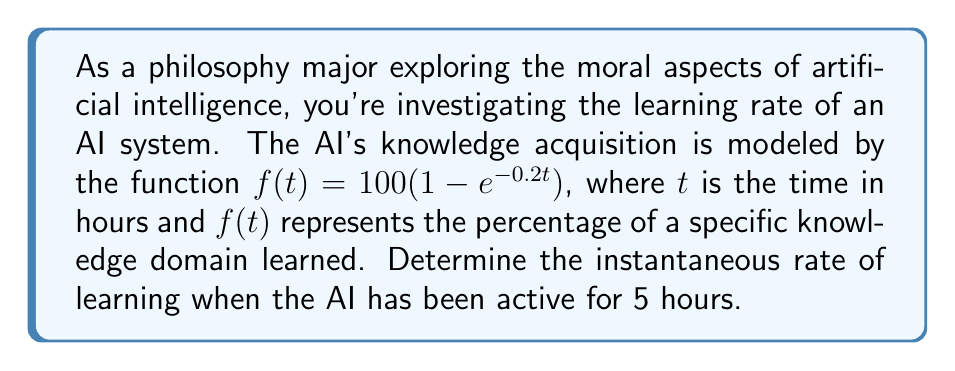Help me with this question. To solve this problem, we need to find the derivative of the given function and evaluate it at $t=5$. This will give us the instantaneous rate of change, or the learning rate, at that specific time.

1. Given function: $f(t) = 100(1 - e^{-0.2t})$

2. To find the derivative, we use the chain rule:
   $$\frac{d}{dt}[f(t)] = 100 \cdot \frac{d}{dt}[1 - e^{-0.2t}]$$
   $$= 100 \cdot (-1) \cdot \frac{d}{dt}[e^{-0.2t}]$$
   $$= -100 \cdot e^{-0.2t} \cdot \frac{d}{dt}[-0.2t]$$
   $$= -100 \cdot e^{-0.2t} \cdot (-0.2)$$
   $$= 20 \cdot e^{-0.2t}$$

3. So, the derivative (rate of change) function is:
   $$f'(t) = 20e^{-0.2t}$$

4. To find the instantaneous rate of learning at $t=5$, we evaluate $f'(5)$:
   $$f'(5) = 20e^{-0.2(5)}$$
   $$= 20e^{-1}$$
   $$= 20 \cdot \frac{1}{e}$$
   $$\approx 7.3576$$

This result represents the percentage increase in knowledge per hour at $t=5$.
Answer: The instantaneous rate of learning when the AI has been active for 5 hours is approximately 7.3576% per hour. 